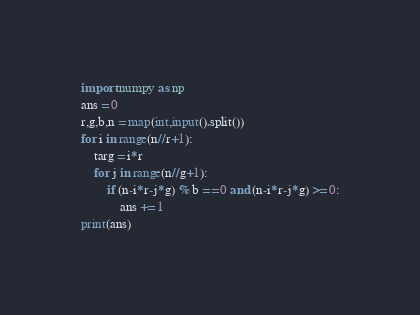<code> <loc_0><loc_0><loc_500><loc_500><_Python_>import numpy as np
ans = 0
r,g,b,n = map(int,input().split())
for i in range(n//r+1):
	targ = i*r
	for j in range(n//g+1):
		if (n-i*r-j*g) % b == 0 and (n-i*r-j*g) >= 0:
			ans += 1
print(ans)</code> 